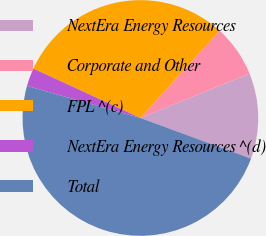<chart> <loc_0><loc_0><loc_500><loc_500><pie_chart><fcel>NextEra Energy Resources<fcel>Corporate and Other<fcel>FPL ^(c)<fcel>NextEra Energy Resources ^(d)<fcel>Total<nl><fcel>11.75%<fcel>7.12%<fcel>29.84%<fcel>2.5%<fcel>48.78%<nl></chart> 